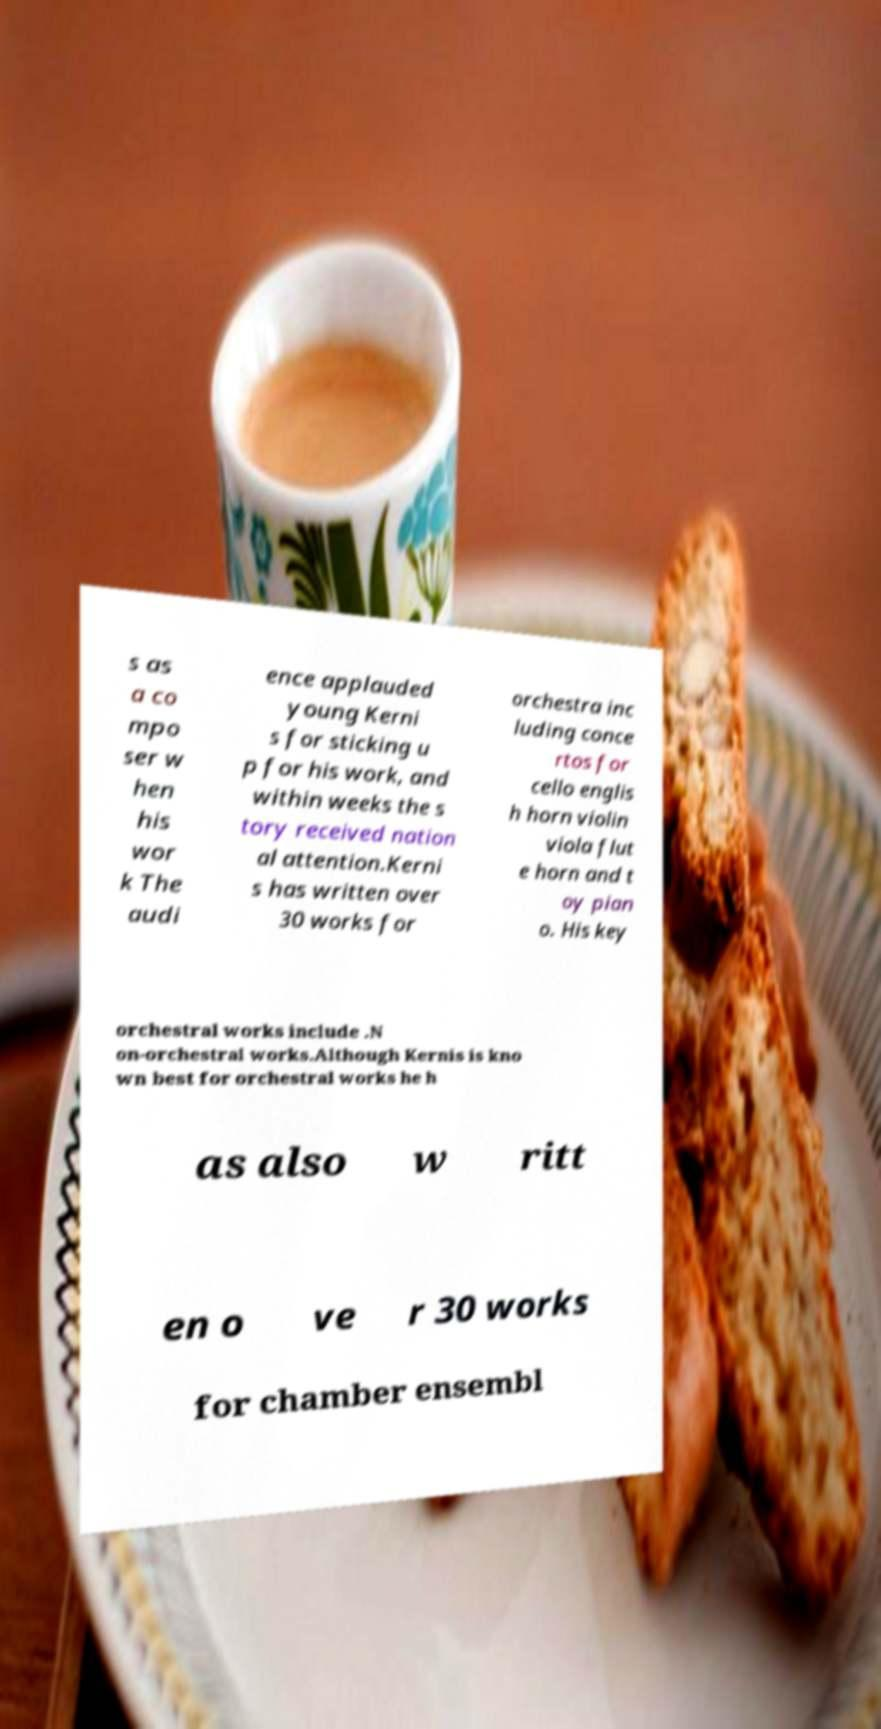There's text embedded in this image that I need extracted. Can you transcribe it verbatim? s as a co mpo ser w hen his wor k The audi ence applauded young Kerni s for sticking u p for his work, and within weeks the s tory received nation al attention.Kerni s has written over 30 works for orchestra inc luding conce rtos for cello englis h horn violin viola flut e horn and t oy pian o. His key orchestral works include .N on-orchestral works.Although Kernis is kno wn best for orchestral works he h as also w ritt en o ve r 30 works for chamber ensembl 